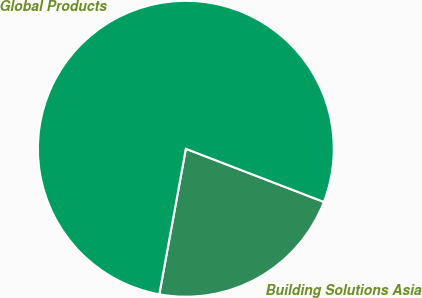Convert chart to OTSL. <chart><loc_0><loc_0><loc_500><loc_500><pie_chart><fcel>Building Solutions Asia<fcel>Global Products<nl><fcel>22.02%<fcel>77.98%<nl></chart> 